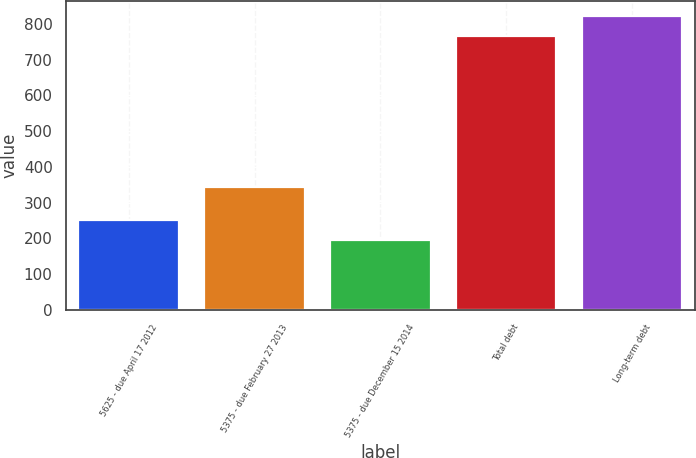Convert chart to OTSL. <chart><loc_0><loc_0><loc_500><loc_500><bar_chart><fcel>5625 - due April 17 2012<fcel>5375 - due February 27 2013<fcel>5375 - due December 15 2014<fcel>Total debt<fcel>Long-term debt<nl><fcel>252.14<fcel>343.4<fcel>195.1<fcel>765.5<fcel>822.54<nl></chart> 